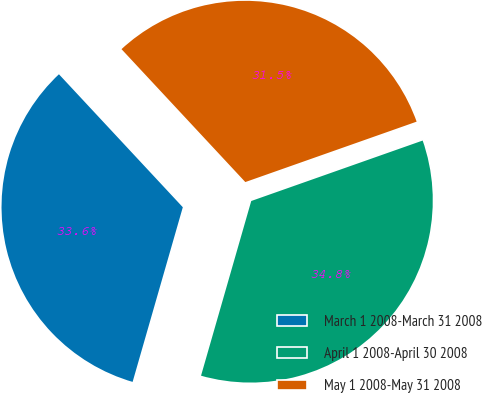<chart> <loc_0><loc_0><loc_500><loc_500><pie_chart><fcel>March 1 2008-March 31 2008<fcel>April 1 2008-April 30 2008<fcel>May 1 2008-May 31 2008<nl><fcel>33.61%<fcel>34.85%<fcel>31.54%<nl></chart> 